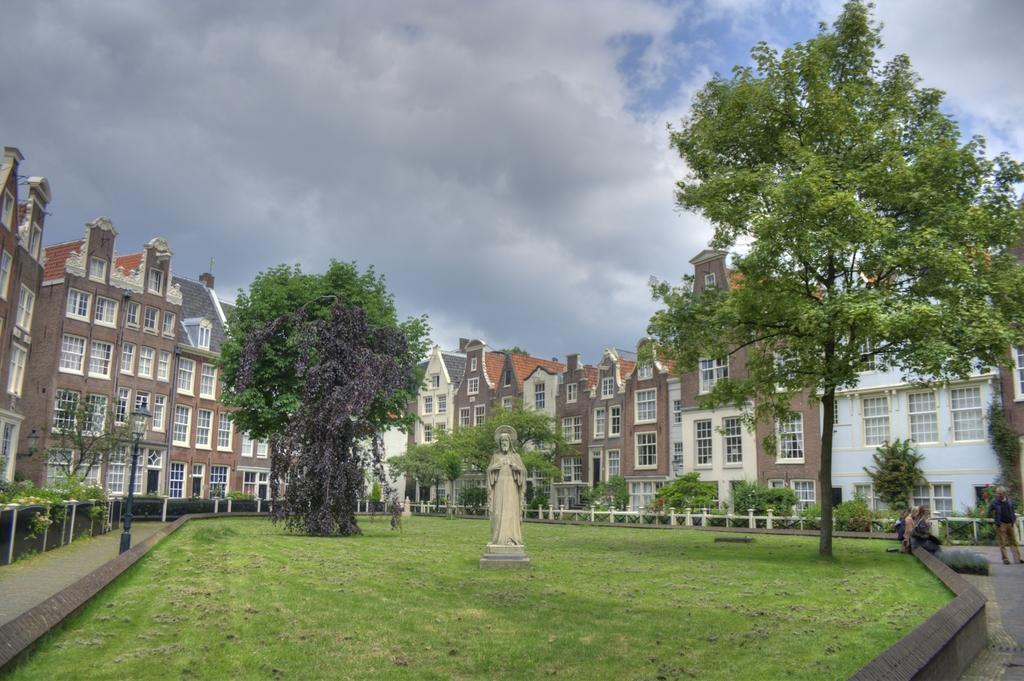How would you summarize this image in a sentence or two? In the image I can see a statue on the ground and also I can see some trees and buildings. 